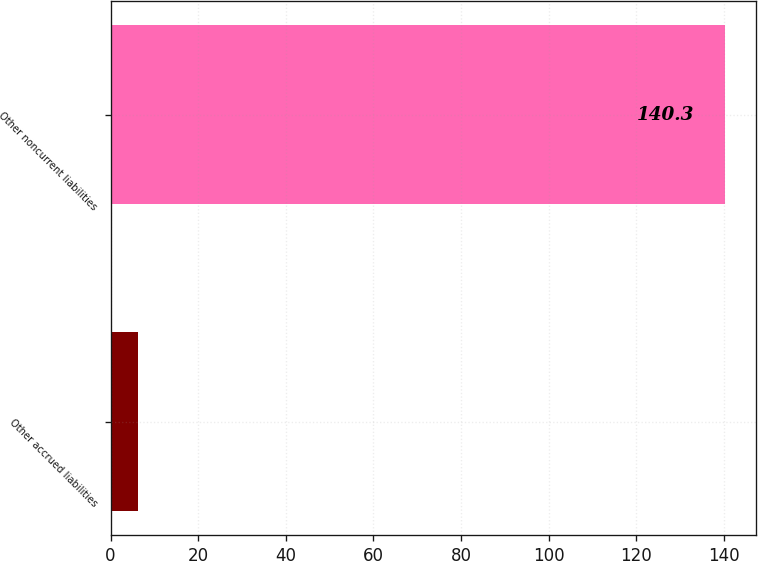Convert chart to OTSL. <chart><loc_0><loc_0><loc_500><loc_500><bar_chart><fcel>Other accrued liabilities<fcel>Other noncurrent liabilities<nl><fcel>6.3<fcel>140.3<nl></chart> 